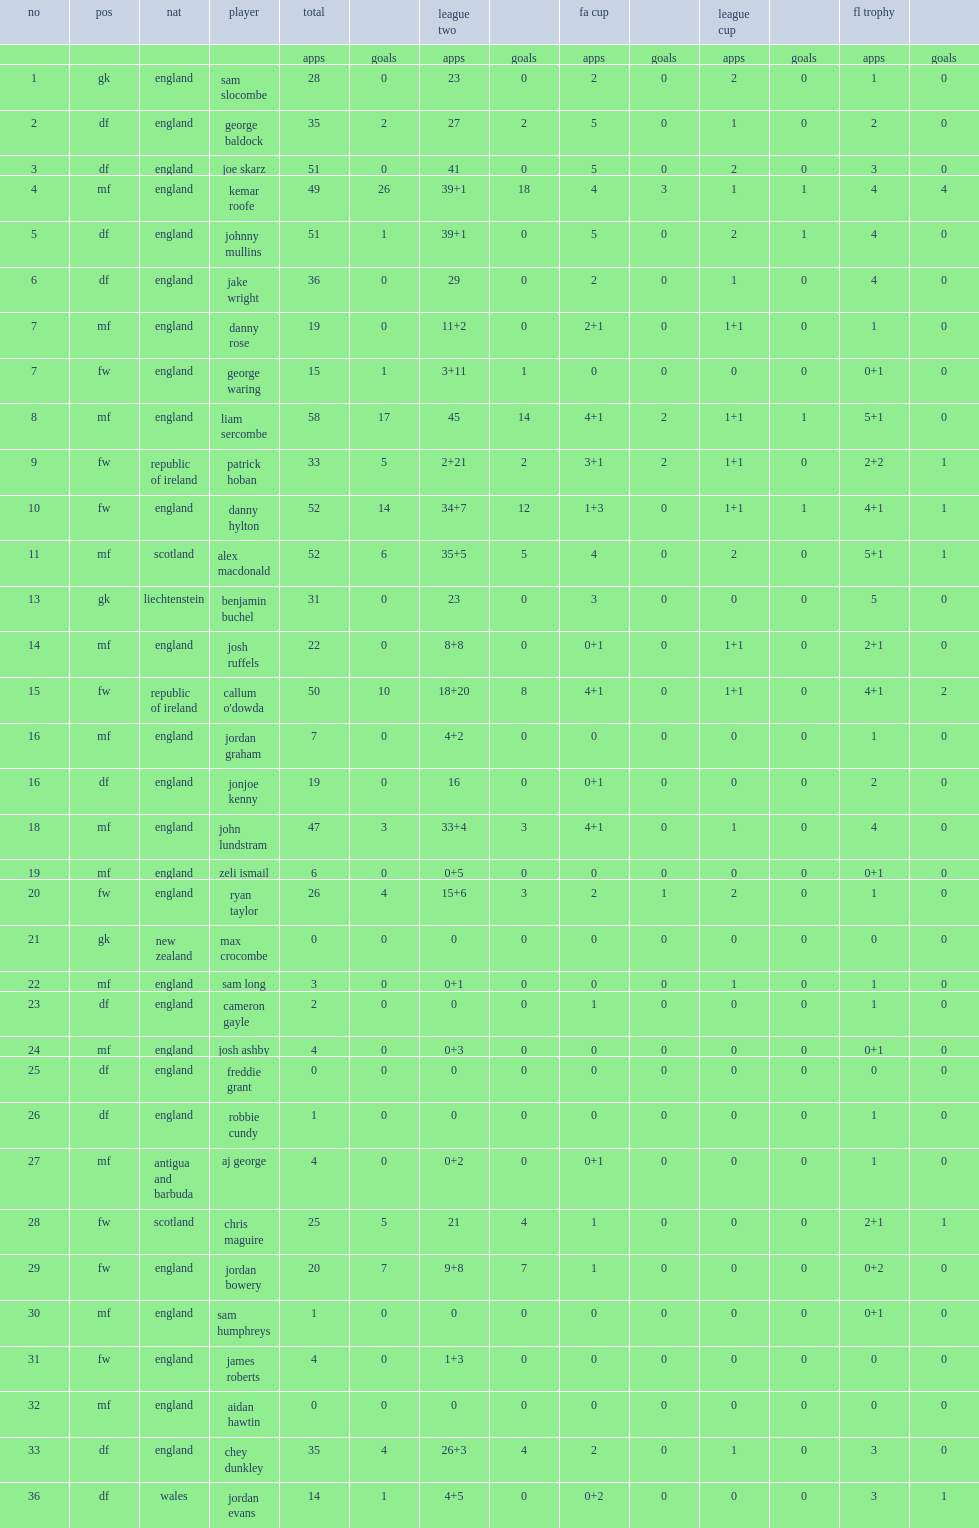What cups or leagues did the oxford united participated in expect for the league two? Fa cup league cup fl trophy. 